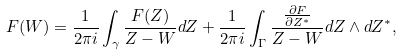<formula> <loc_0><loc_0><loc_500><loc_500>F ( W ) = \frac { 1 } { 2 \pi { i } } \int _ { \gamma } \frac { F ( Z ) } { Z - W } d Z + \frac { 1 } { 2 \pi { i } } \int _ { \Gamma } \frac { \frac { \partial F } { \partial Z ^ { * } } } { Z - W } d Z \wedge d Z ^ { * } ,</formula> 